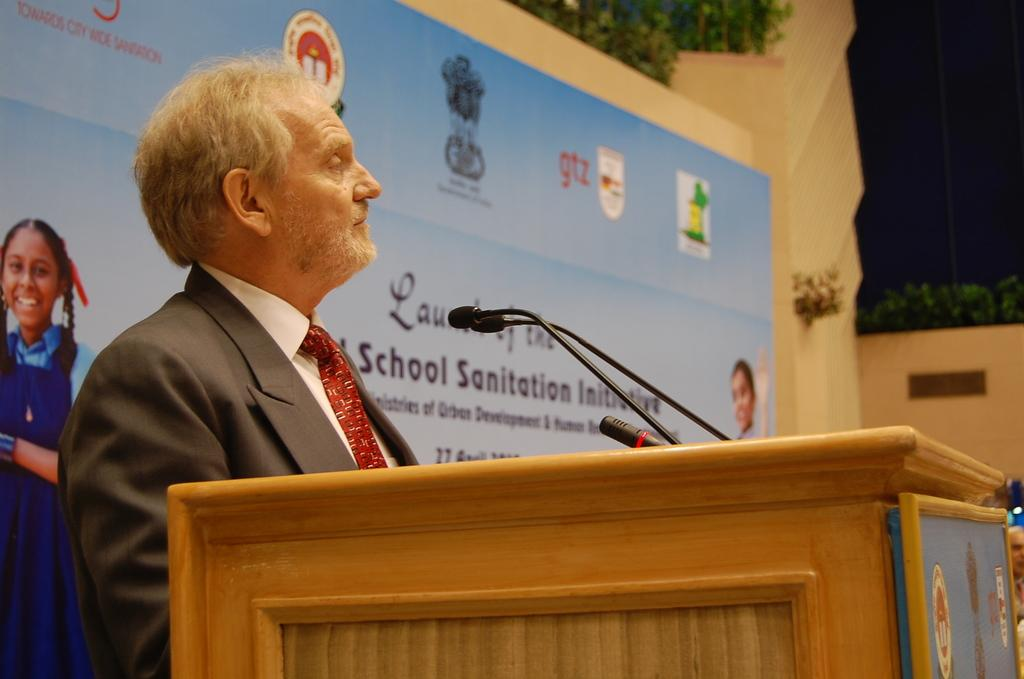What is the man in the image doing? The man is standing at the podium in the image. What is attached to the podium? Mics are attached to the podium. What can be seen in the background of the image? There is an advertisement on the wall and plants in the background of the image. What type of blade is being used to trim the plants in the image? There is no blade or plant trimming activity visible in the image. 